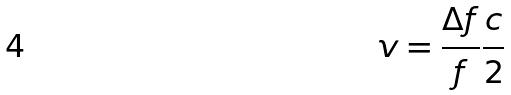Convert formula to latex. <formula><loc_0><loc_0><loc_500><loc_500>v = \frac { \Delta f } { f } \frac { c } { 2 }</formula> 